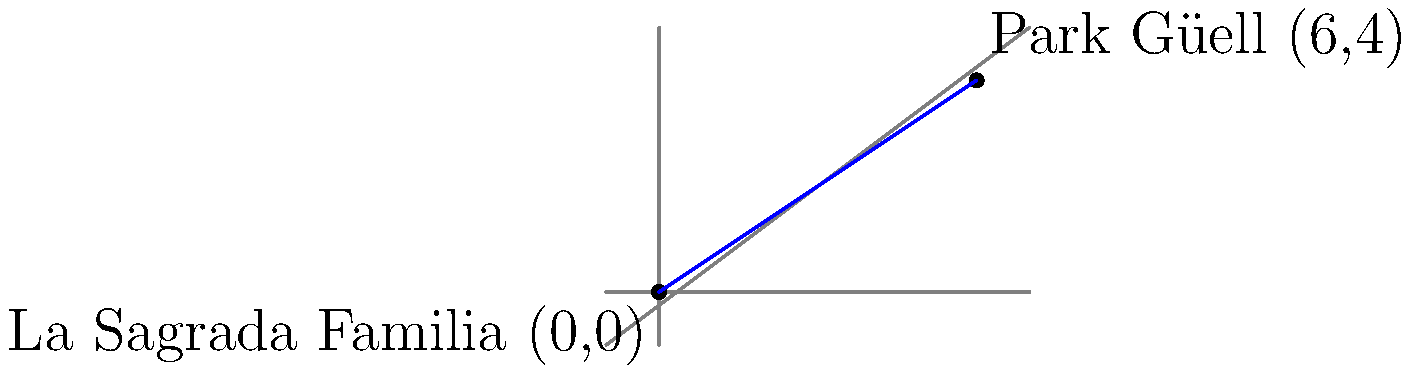As you explore Barcelona's culinary scene, you decide to take a gastronomic journey from La Sagrada Familia to Park Güell, two iconic landmarks of the city. If La Sagrada Familia is located at coordinates (0,0) and Park Güell at (6,4) on a city map, what is the equation of the line connecting these two landmarks? Express your answer in slope-intercept form. Let's approach this step-by-step:

1) To find the equation of a line in slope-intercept form ($y = mx + b$), we need to calculate the slope (m) and y-intercept (b).

2) First, let's calculate the slope using the slope formula:
   $m = \frac{y_2 - y_1}{x_2 - x_1}$
   
   Where $(x_1, y_1)$ is La Sagrada Familia (0,0) and $(x_2, y_2)$ is Park Güell (6,4)

3) Plugging in the values:
   $m = \frac{4 - 0}{6 - 0} = \frac{4}{6} = \frac{2}{3}$

4) Now that we have the slope, we can use the point-slope form of a line to find the y-intercept:
   $y - y_1 = m(x - x_1)$

5) Let's use the point (0,0) and plug in our known values:
   $y - 0 = \frac{2}{3}(x - 0)$

6) Simplify:
   $y = \frac{2}{3}x$

7) This is already in slope-intercept form $(y = mx + b)$, where $m = \frac{2}{3}$ and $b = 0$

Therefore, the equation of the line connecting La Sagrada Familia and Park Güell is $y = \frac{2}{3}x$.
Answer: $y = \frac{2}{3}x$ 